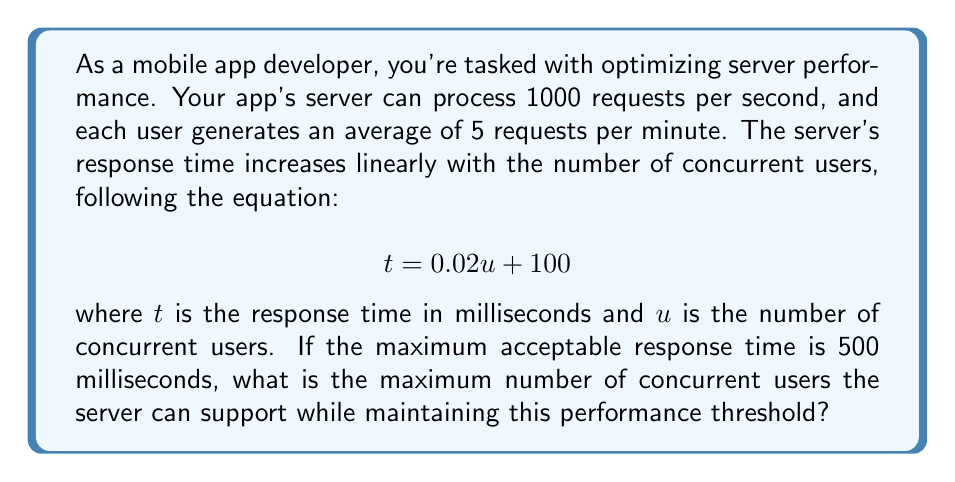Could you help me with this problem? To solve this problem, we'll follow these steps:

1) First, we need to understand the given equation:
   $$ t = 0.02u + 100 $$
   where $t$ is the response time in milliseconds and $u$ is the number of concurrent users.

2) We're told that the maximum acceptable response time is 500 milliseconds. Let's substitute this into our equation:
   $$ 500 = 0.02u + 100 $$

3) Now we can solve for $u$:
   $$ 500 - 100 = 0.02u $$
   $$ 400 = 0.02u $$
   $$ u = 400 / 0.02 = 20,000 $$

4) This gives us the maximum number of concurrent users based on response time. However, we also need to check if the server can handle this many users based on its request processing capacity.

5) The server can process 1000 requests per second. Each user generates 5 requests per minute, which is equivalent to 5/60 = 1/12 requests per second.

6) To find how many users the server can handle based on request processing:
   $$ 1000 = u * (1/12) $$
   $$ u = 1000 * 12 = 12,000 $$

7) The actual maximum number of concurrent users will be the smaller of these two values, as both conditions must be satisfied.

Therefore, the maximum number of concurrent users the server can support is 12,000.
Answer: 12,000 concurrent users 